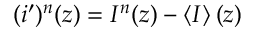Convert formula to latex. <formula><loc_0><loc_0><loc_500><loc_500>( i ^ { \prime } ) ^ { n } ( z ) = I ^ { n } ( z ) - \left < I \right > ( z )</formula> 